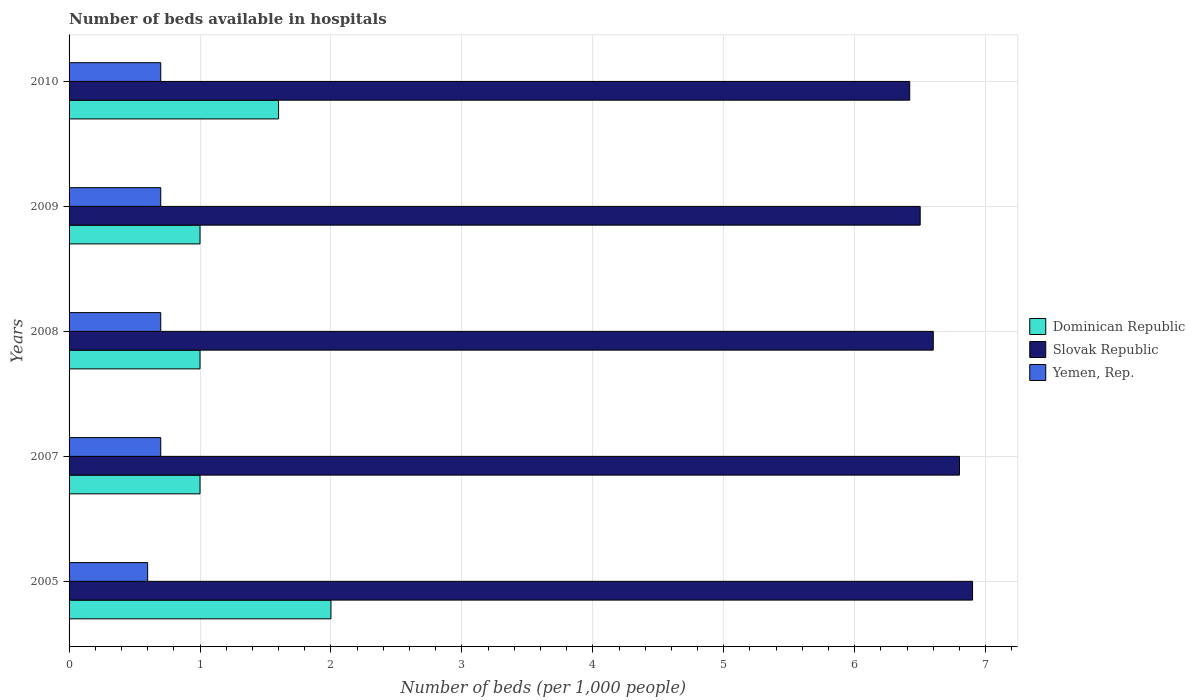How many groups of bars are there?
Your response must be concise. 5. What is the label of the 5th group of bars from the top?
Your answer should be very brief. 2005. What is the number of beds in the hospiatls of in Slovak Republic in 2010?
Your response must be concise. 6.42. Across all years, what is the minimum number of beds in the hospiatls of in Yemen, Rep.?
Make the answer very short. 0.6. In which year was the number of beds in the hospiatls of in Dominican Republic maximum?
Give a very brief answer. 2005. What is the total number of beds in the hospiatls of in Yemen, Rep. in the graph?
Provide a succinct answer. 3.4. What is the difference between the number of beds in the hospiatls of in Yemen, Rep. in 2009 and the number of beds in the hospiatls of in Dominican Republic in 2008?
Ensure brevity in your answer.  -0.3. What is the average number of beds in the hospiatls of in Dominican Republic per year?
Provide a short and direct response. 1.32. In the year 2007, what is the difference between the number of beds in the hospiatls of in Slovak Republic and number of beds in the hospiatls of in Yemen, Rep.?
Make the answer very short. 6.1. In how many years, is the number of beds in the hospiatls of in Slovak Republic greater than 3.6 ?
Give a very brief answer. 5. What is the ratio of the number of beds in the hospiatls of in Yemen, Rep. in 2009 to that in 2010?
Your answer should be compact. 1. Is the difference between the number of beds in the hospiatls of in Slovak Republic in 2005 and 2010 greater than the difference between the number of beds in the hospiatls of in Yemen, Rep. in 2005 and 2010?
Provide a succinct answer. Yes. Is the sum of the number of beds in the hospiatls of in Dominican Republic in 2005 and 2010 greater than the maximum number of beds in the hospiatls of in Yemen, Rep. across all years?
Your response must be concise. Yes. What does the 1st bar from the top in 2008 represents?
Provide a short and direct response. Yemen, Rep. What does the 2nd bar from the bottom in 2009 represents?
Make the answer very short. Slovak Republic. Is it the case that in every year, the sum of the number of beds in the hospiatls of in Slovak Republic and number of beds in the hospiatls of in Dominican Republic is greater than the number of beds in the hospiatls of in Yemen, Rep.?
Provide a succinct answer. Yes. How many bars are there?
Offer a terse response. 15. Does the graph contain any zero values?
Offer a terse response. No. Where does the legend appear in the graph?
Keep it short and to the point. Center right. How many legend labels are there?
Offer a terse response. 3. What is the title of the graph?
Your answer should be very brief. Number of beds available in hospitals. What is the label or title of the X-axis?
Make the answer very short. Number of beds (per 1,0 people). What is the Number of beds (per 1,000 people) in Slovak Republic in 2005?
Your answer should be compact. 6.9. What is the Number of beds (per 1,000 people) in Yemen, Rep. in 2005?
Provide a succinct answer. 0.6. What is the Number of beds (per 1,000 people) in Dominican Republic in 2007?
Keep it short and to the point. 1. What is the Number of beds (per 1,000 people) of Slovak Republic in 2007?
Provide a succinct answer. 6.8. What is the Number of beds (per 1,000 people) in Slovak Republic in 2008?
Keep it short and to the point. 6.6. What is the Number of beds (per 1,000 people) in Slovak Republic in 2009?
Offer a very short reply. 6.5. What is the Number of beds (per 1,000 people) of Yemen, Rep. in 2009?
Ensure brevity in your answer.  0.7. What is the Number of beds (per 1,000 people) of Slovak Republic in 2010?
Provide a short and direct response. 6.42. Across all years, what is the maximum Number of beds (per 1,000 people) of Dominican Republic?
Your answer should be very brief. 2. Across all years, what is the minimum Number of beds (per 1,000 people) in Slovak Republic?
Offer a very short reply. 6.42. What is the total Number of beds (per 1,000 people) of Slovak Republic in the graph?
Offer a very short reply. 33.22. What is the total Number of beds (per 1,000 people) of Yemen, Rep. in the graph?
Provide a short and direct response. 3.4. What is the difference between the Number of beds (per 1,000 people) in Dominican Republic in 2005 and that in 2007?
Your answer should be compact. 1. What is the difference between the Number of beds (per 1,000 people) in Yemen, Rep. in 2005 and that in 2007?
Your answer should be very brief. -0.1. What is the difference between the Number of beds (per 1,000 people) of Yemen, Rep. in 2005 and that in 2008?
Your response must be concise. -0.1. What is the difference between the Number of beds (per 1,000 people) in Dominican Republic in 2005 and that in 2009?
Your answer should be compact. 1. What is the difference between the Number of beds (per 1,000 people) in Yemen, Rep. in 2005 and that in 2009?
Your answer should be very brief. -0.1. What is the difference between the Number of beds (per 1,000 people) in Dominican Republic in 2005 and that in 2010?
Provide a succinct answer. 0.4. What is the difference between the Number of beds (per 1,000 people) in Slovak Republic in 2005 and that in 2010?
Give a very brief answer. 0.48. What is the difference between the Number of beds (per 1,000 people) of Dominican Republic in 2007 and that in 2008?
Your answer should be very brief. 0. What is the difference between the Number of beds (per 1,000 people) in Slovak Republic in 2007 and that in 2008?
Give a very brief answer. 0.2. What is the difference between the Number of beds (per 1,000 people) in Yemen, Rep. in 2007 and that in 2008?
Your response must be concise. 0. What is the difference between the Number of beds (per 1,000 people) in Slovak Republic in 2007 and that in 2010?
Give a very brief answer. 0.38. What is the difference between the Number of beds (per 1,000 people) of Dominican Republic in 2008 and that in 2009?
Your response must be concise. 0. What is the difference between the Number of beds (per 1,000 people) of Slovak Republic in 2008 and that in 2009?
Offer a terse response. 0.1. What is the difference between the Number of beds (per 1,000 people) in Dominican Republic in 2008 and that in 2010?
Offer a very short reply. -0.6. What is the difference between the Number of beds (per 1,000 people) of Slovak Republic in 2008 and that in 2010?
Provide a short and direct response. 0.18. What is the difference between the Number of beds (per 1,000 people) of Yemen, Rep. in 2008 and that in 2010?
Make the answer very short. 0. What is the difference between the Number of beds (per 1,000 people) of Dominican Republic in 2009 and that in 2010?
Provide a short and direct response. -0.6. What is the difference between the Number of beds (per 1,000 people) of Slovak Republic in 2009 and that in 2010?
Make the answer very short. 0.08. What is the difference between the Number of beds (per 1,000 people) in Dominican Republic in 2005 and the Number of beds (per 1,000 people) in Slovak Republic in 2007?
Provide a short and direct response. -4.8. What is the difference between the Number of beds (per 1,000 people) of Dominican Republic in 2005 and the Number of beds (per 1,000 people) of Yemen, Rep. in 2007?
Offer a terse response. 1.3. What is the difference between the Number of beds (per 1,000 people) in Dominican Republic in 2005 and the Number of beds (per 1,000 people) in Yemen, Rep. in 2008?
Ensure brevity in your answer.  1.3. What is the difference between the Number of beds (per 1,000 people) in Dominican Republic in 2005 and the Number of beds (per 1,000 people) in Yemen, Rep. in 2009?
Your response must be concise. 1.3. What is the difference between the Number of beds (per 1,000 people) in Slovak Republic in 2005 and the Number of beds (per 1,000 people) in Yemen, Rep. in 2009?
Provide a short and direct response. 6.2. What is the difference between the Number of beds (per 1,000 people) in Dominican Republic in 2005 and the Number of beds (per 1,000 people) in Slovak Republic in 2010?
Give a very brief answer. -4.42. What is the difference between the Number of beds (per 1,000 people) in Dominican Republic in 2005 and the Number of beds (per 1,000 people) in Yemen, Rep. in 2010?
Give a very brief answer. 1.3. What is the difference between the Number of beds (per 1,000 people) of Slovak Republic in 2005 and the Number of beds (per 1,000 people) of Yemen, Rep. in 2010?
Give a very brief answer. 6.2. What is the difference between the Number of beds (per 1,000 people) in Dominican Republic in 2007 and the Number of beds (per 1,000 people) in Slovak Republic in 2008?
Ensure brevity in your answer.  -5.6. What is the difference between the Number of beds (per 1,000 people) in Slovak Republic in 2007 and the Number of beds (per 1,000 people) in Yemen, Rep. in 2008?
Keep it short and to the point. 6.1. What is the difference between the Number of beds (per 1,000 people) of Dominican Republic in 2007 and the Number of beds (per 1,000 people) of Yemen, Rep. in 2009?
Offer a terse response. 0.3. What is the difference between the Number of beds (per 1,000 people) in Dominican Republic in 2007 and the Number of beds (per 1,000 people) in Slovak Republic in 2010?
Offer a very short reply. -5.42. What is the difference between the Number of beds (per 1,000 people) of Slovak Republic in 2007 and the Number of beds (per 1,000 people) of Yemen, Rep. in 2010?
Offer a terse response. 6.1. What is the difference between the Number of beds (per 1,000 people) of Dominican Republic in 2008 and the Number of beds (per 1,000 people) of Slovak Republic in 2009?
Your answer should be compact. -5.5. What is the difference between the Number of beds (per 1,000 people) of Dominican Republic in 2008 and the Number of beds (per 1,000 people) of Yemen, Rep. in 2009?
Give a very brief answer. 0.3. What is the difference between the Number of beds (per 1,000 people) in Slovak Republic in 2008 and the Number of beds (per 1,000 people) in Yemen, Rep. in 2009?
Offer a terse response. 5.9. What is the difference between the Number of beds (per 1,000 people) of Dominican Republic in 2008 and the Number of beds (per 1,000 people) of Slovak Republic in 2010?
Your response must be concise. -5.42. What is the difference between the Number of beds (per 1,000 people) of Dominican Republic in 2008 and the Number of beds (per 1,000 people) of Yemen, Rep. in 2010?
Provide a short and direct response. 0.3. What is the difference between the Number of beds (per 1,000 people) of Dominican Republic in 2009 and the Number of beds (per 1,000 people) of Slovak Republic in 2010?
Your answer should be very brief. -5.42. What is the difference between the Number of beds (per 1,000 people) in Slovak Republic in 2009 and the Number of beds (per 1,000 people) in Yemen, Rep. in 2010?
Ensure brevity in your answer.  5.8. What is the average Number of beds (per 1,000 people) in Dominican Republic per year?
Offer a terse response. 1.32. What is the average Number of beds (per 1,000 people) of Slovak Republic per year?
Give a very brief answer. 6.64. What is the average Number of beds (per 1,000 people) in Yemen, Rep. per year?
Provide a short and direct response. 0.68. In the year 2007, what is the difference between the Number of beds (per 1,000 people) in Dominican Republic and Number of beds (per 1,000 people) in Slovak Republic?
Your response must be concise. -5.8. In the year 2007, what is the difference between the Number of beds (per 1,000 people) of Dominican Republic and Number of beds (per 1,000 people) of Yemen, Rep.?
Your answer should be compact. 0.3. In the year 2007, what is the difference between the Number of beds (per 1,000 people) of Slovak Republic and Number of beds (per 1,000 people) of Yemen, Rep.?
Ensure brevity in your answer.  6.1. In the year 2008, what is the difference between the Number of beds (per 1,000 people) in Dominican Republic and Number of beds (per 1,000 people) in Yemen, Rep.?
Keep it short and to the point. 0.3. In the year 2008, what is the difference between the Number of beds (per 1,000 people) in Slovak Republic and Number of beds (per 1,000 people) in Yemen, Rep.?
Provide a short and direct response. 5.9. In the year 2009, what is the difference between the Number of beds (per 1,000 people) in Slovak Republic and Number of beds (per 1,000 people) in Yemen, Rep.?
Your response must be concise. 5.8. In the year 2010, what is the difference between the Number of beds (per 1,000 people) in Dominican Republic and Number of beds (per 1,000 people) in Slovak Republic?
Offer a terse response. -4.82. In the year 2010, what is the difference between the Number of beds (per 1,000 people) in Slovak Republic and Number of beds (per 1,000 people) in Yemen, Rep.?
Give a very brief answer. 5.72. What is the ratio of the Number of beds (per 1,000 people) of Slovak Republic in 2005 to that in 2007?
Provide a short and direct response. 1.01. What is the ratio of the Number of beds (per 1,000 people) of Yemen, Rep. in 2005 to that in 2007?
Keep it short and to the point. 0.86. What is the ratio of the Number of beds (per 1,000 people) in Dominican Republic in 2005 to that in 2008?
Your answer should be compact. 2. What is the ratio of the Number of beds (per 1,000 people) of Slovak Republic in 2005 to that in 2008?
Provide a succinct answer. 1.05. What is the ratio of the Number of beds (per 1,000 people) in Yemen, Rep. in 2005 to that in 2008?
Your answer should be compact. 0.86. What is the ratio of the Number of beds (per 1,000 people) in Dominican Republic in 2005 to that in 2009?
Your answer should be compact. 2. What is the ratio of the Number of beds (per 1,000 people) in Slovak Republic in 2005 to that in 2009?
Offer a very short reply. 1.06. What is the ratio of the Number of beds (per 1,000 people) of Slovak Republic in 2005 to that in 2010?
Provide a succinct answer. 1.07. What is the ratio of the Number of beds (per 1,000 people) in Slovak Republic in 2007 to that in 2008?
Provide a succinct answer. 1.03. What is the ratio of the Number of beds (per 1,000 people) in Slovak Republic in 2007 to that in 2009?
Make the answer very short. 1.05. What is the ratio of the Number of beds (per 1,000 people) of Slovak Republic in 2007 to that in 2010?
Offer a very short reply. 1.06. What is the ratio of the Number of beds (per 1,000 people) in Yemen, Rep. in 2007 to that in 2010?
Provide a succinct answer. 1. What is the ratio of the Number of beds (per 1,000 people) of Dominican Republic in 2008 to that in 2009?
Provide a succinct answer. 1. What is the ratio of the Number of beds (per 1,000 people) in Slovak Republic in 2008 to that in 2009?
Provide a short and direct response. 1.02. What is the ratio of the Number of beds (per 1,000 people) of Yemen, Rep. in 2008 to that in 2009?
Your answer should be compact. 1. What is the ratio of the Number of beds (per 1,000 people) of Slovak Republic in 2008 to that in 2010?
Provide a short and direct response. 1.03. What is the ratio of the Number of beds (per 1,000 people) in Dominican Republic in 2009 to that in 2010?
Give a very brief answer. 0.62. What is the ratio of the Number of beds (per 1,000 people) in Slovak Republic in 2009 to that in 2010?
Offer a terse response. 1.01. What is the ratio of the Number of beds (per 1,000 people) of Yemen, Rep. in 2009 to that in 2010?
Give a very brief answer. 1. What is the difference between the highest and the second highest Number of beds (per 1,000 people) of Dominican Republic?
Provide a succinct answer. 0.4. What is the difference between the highest and the second highest Number of beds (per 1,000 people) of Slovak Republic?
Your response must be concise. 0.1. What is the difference between the highest and the second highest Number of beds (per 1,000 people) in Yemen, Rep.?
Ensure brevity in your answer.  0. What is the difference between the highest and the lowest Number of beds (per 1,000 people) in Dominican Republic?
Give a very brief answer. 1. What is the difference between the highest and the lowest Number of beds (per 1,000 people) in Slovak Republic?
Your answer should be compact. 0.48. 